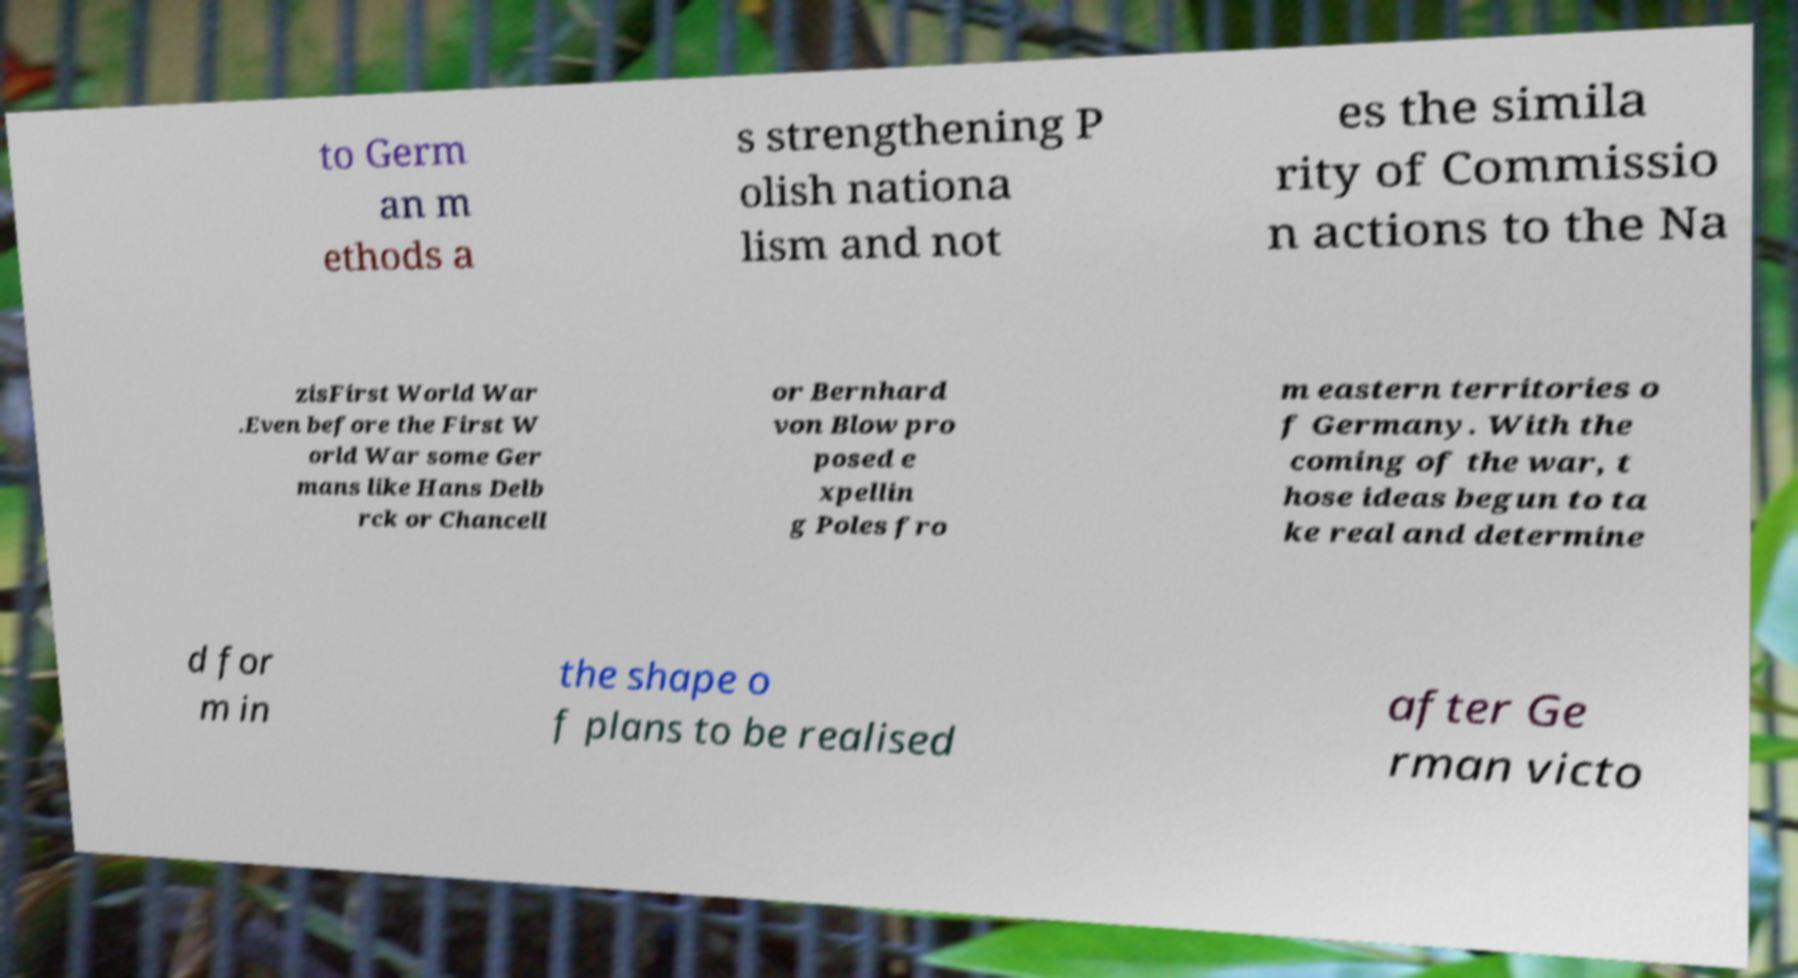What messages or text are displayed in this image? I need them in a readable, typed format. to Germ an m ethods a s strengthening P olish nationa lism and not es the simila rity of Commissio n actions to the Na zisFirst World War .Even before the First W orld War some Ger mans like Hans Delb rck or Chancell or Bernhard von Blow pro posed e xpellin g Poles fro m eastern territories o f Germany. With the coming of the war, t hose ideas begun to ta ke real and determine d for m in the shape o f plans to be realised after Ge rman victo 